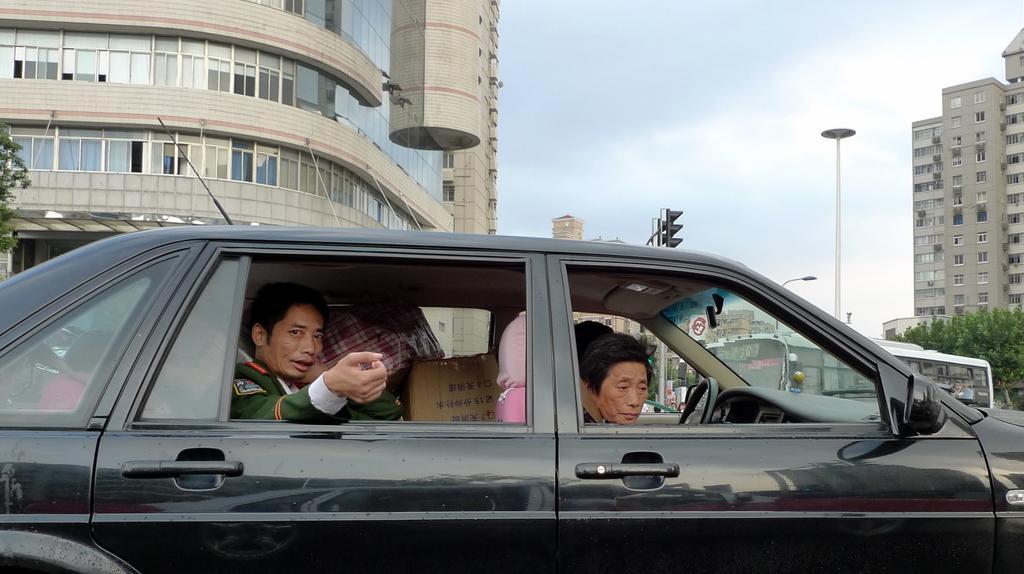Can you describe this image briefly? There are three people with some objects sitting inside the car. This is a black color car. I can see a bus which is white in color. These are the buildings with windows. I can see trees here. This looks like a pole. This is a traffic signal. 